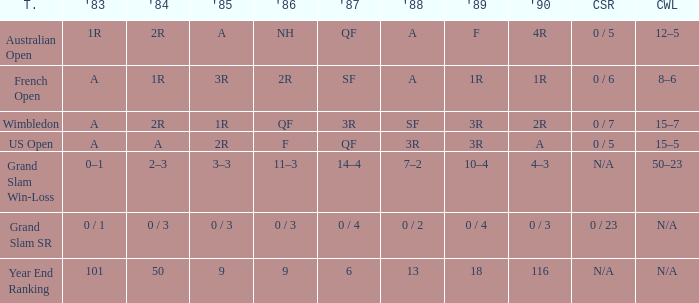What tournament has 0 / 5 as career SR and A as 1983? US Open. 